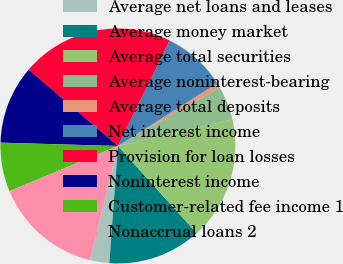Convert chart to OTSL. <chart><loc_0><loc_0><loc_500><loc_500><pie_chart><fcel>Average net loans and leases<fcel>Average money market<fcel>Average total securities<fcel>Average noninterest-bearing<fcel>Average total deposits<fcel>Net interest income<fcel>Provision for loan losses<fcel>Noninterest income<fcel>Customer-related fee income 1<fcel>Nonaccrual loans 2<nl><fcel>2.67%<fcel>12.85%<fcel>16.92%<fcel>4.71%<fcel>0.64%<fcel>8.78%<fcel>20.99%<fcel>10.81%<fcel>6.74%<fcel>14.89%<nl></chart> 